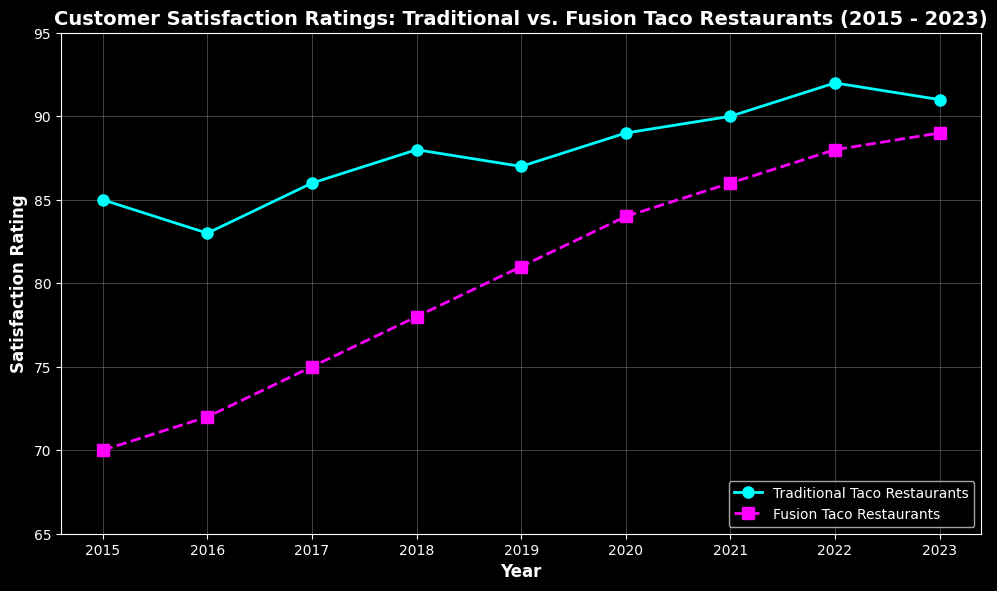Which type of taco restaurant had higher customer satisfaction ratings in 2023? In the figure, the satisfaction rating for Traditional Taco Restaurants in 2023 is 91, while for Fusion Taco Restaurants it is 89. So, Traditional Taco Restaurants had higher ratings.
Answer: Traditional Taco Restaurants What is the trend observed in customer satisfaction ratings for Fusion Taco Restaurants from 2015 to 2023? By visual inspection, the satisfaction ratings for Fusion Taco Restaurants show a continuous increase from 70 in 2015 to 89 in 2023.
Answer: Increasing What was the difference in customer satisfaction ratings between Traditional and Fusion Taco Restaurants in 2018? In 2018, the satisfaction ratings were 88 for Traditional Taco Restaurants and 78 for Fusion Taco Restaurants. The difference is 88 - 78 = 10.
Answer: 10 Between which consecutive years did Traditional Taco Restaurants experience a decrease in customer satisfaction? Observing the plot, the satisfaction rating for Traditional Taco Restaurants decreased from 88 in 2018 to 87 in 2019.
Answer: 2018 to 2019 Which type of taco restaurant consistently had higher satisfaction ratings over the given years? From 2015 to 2023, the plot shows that Traditional Taco Restaurants always had higher ratings than Fusion Taco Restaurants each year.
Answer: Traditional Taco Restaurants What is the average customer satisfaction rating for Traditional Taco Restaurants between 2015 and 2023? Adding the ratings for each year (85 + 83 + 86 + 88 + 87 + 89 + 90 + 92 + 91) and dividing by the number of years (9), we get (791 / 9) ≈ 87.89.
Answer: 87.89 In which year did Fusion Taco Restaurants see the highest increase in customer satisfaction rating compared to the previous year? Comparing the yearly increments, the largest increase for Fusion Taco Restaurants occurs between 2017 and 2018, where the rating increased from 75 to 78, an increase of 3 points.
Answer: 2018 What color line represents the customer satisfaction ratings for Traditional Taco Restaurants? By examining the visual representation, the line for Traditional Taco Restaurants is depicted in a cyan color with circle markers.
Answer: Cyan What is the overall trend in customer satisfaction ratings for Traditional Taco Restaurants from 2015 to 2023? The plot shows a general upward trend in satisfaction ratings for Traditional Taco Restaurants, starting from 85 in 2015 and reaching 91 in 2023.
Answer: Upward trend What is the median satisfaction rating for Fusion Taco Restaurants over the given period? Listing the ratings (70, 72, 75, 78, 81, 84, 86, 88, 89) and finding the middle value, which is the 5th number, gives a median of 81.
Answer: 81 